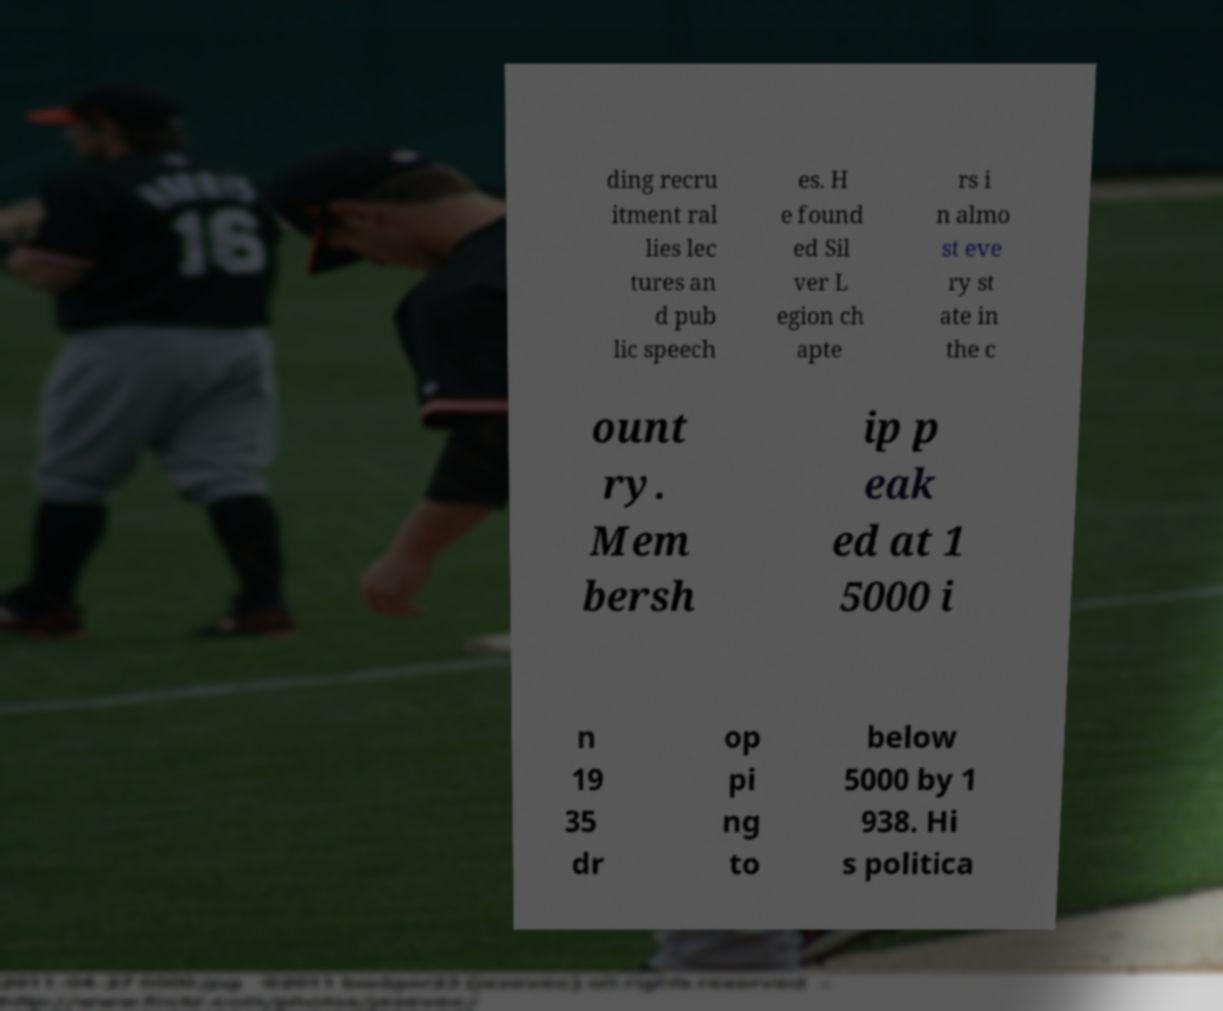Can you accurately transcribe the text from the provided image for me? ding recru itment ral lies lec tures an d pub lic speech es. H e found ed Sil ver L egion ch apte rs i n almo st eve ry st ate in the c ount ry. Mem bersh ip p eak ed at 1 5000 i n 19 35 dr op pi ng to below 5000 by 1 938. Hi s politica 